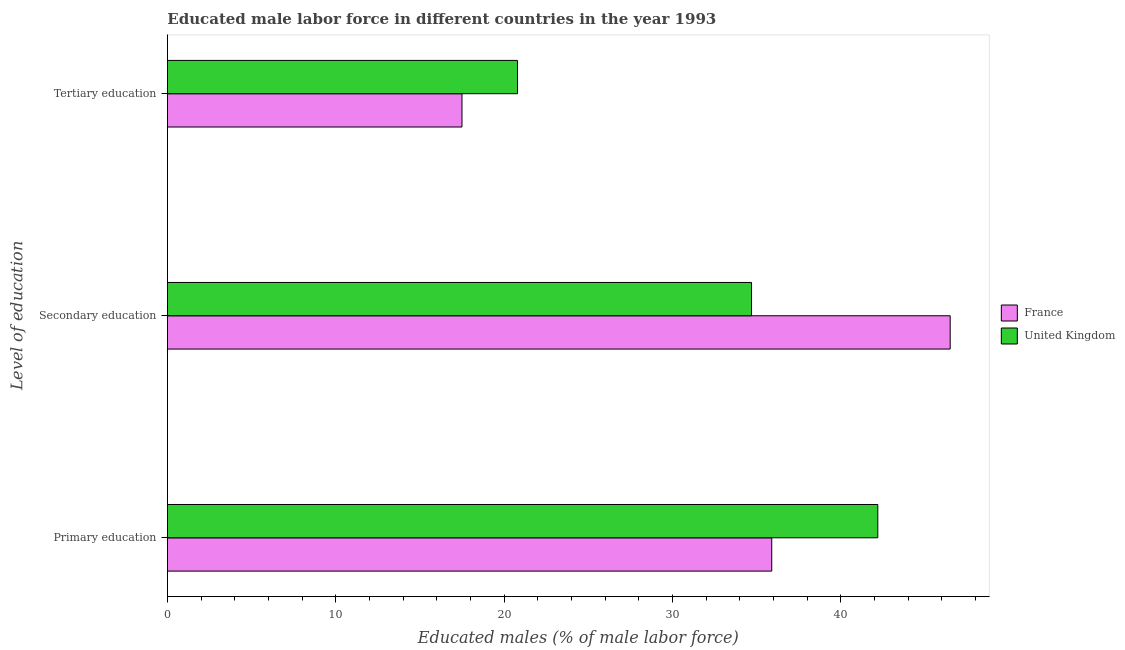Are the number of bars on each tick of the Y-axis equal?
Offer a very short reply. Yes. How many bars are there on the 1st tick from the top?
Your answer should be very brief. 2. What is the label of the 1st group of bars from the top?
Provide a succinct answer. Tertiary education. What is the percentage of male labor force who received primary education in United Kingdom?
Offer a very short reply. 42.2. Across all countries, what is the maximum percentage of male labor force who received primary education?
Offer a terse response. 42.2. Across all countries, what is the minimum percentage of male labor force who received primary education?
Offer a terse response. 35.9. In which country was the percentage of male labor force who received tertiary education maximum?
Provide a succinct answer. United Kingdom. What is the total percentage of male labor force who received secondary education in the graph?
Your answer should be compact. 81.2. What is the difference between the percentage of male labor force who received primary education in France and that in United Kingdom?
Your response must be concise. -6.3. What is the difference between the percentage of male labor force who received secondary education in United Kingdom and the percentage of male labor force who received tertiary education in France?
Make the answer very short. 17.2. What is the average percentage of male labor force who received secondary education per country?
Ensure brevity in your answer.  40.6. What is the difference between the percentage of male labor force who received primary education and percentage of male labor force who received tertiary education in United Kingdom?
Your response must be concise. 21.4. In how many countries, is the percentage of male labor force who received primary education greater than 4 %?
Provide a succinct answer. 2. What is the ratio of the percentage of male labor force who received secondary education in France to that in United Kingdom?
Provide a short and direct response. 1.34. What is the difference between the highest and the second highest percentage of male labor force who received primary education?
Your answer should be very brief. 6.3. What is the difference between the highest and the lowest percentage of male labor force who received primary education?
Provide a succinct answer. 6.3. What does the 1st bar from the bottom in Secondary education represents?
Your answer should be compact. France. How many bars are there?
Your response must be concise. 6. How many countries are there in the graph?
Offer a very short reply. 2. Does the graph contain any zero values?
Ensure brevity in your answer.  No. How are the legend labels stacked?
Keep it short and to the point. Vertical. What is the title of the graph?
Your response must be concise. Educated male labor force in different countries in the year 1993. Does "Kazakhstan" appear as one of the legend labels in the graph?
Your response must be concise. No. What is the label or title of the X-axis?
Offer a terse response. Educated males (% of male labor force). What is the label or title of the Y-axis?
Your answer should be very brief. Level of education. What is the Educated males (% of male labor force) of France in Primary education?
Provide a succinct answer. 35.9. What is the Educated males (% of male labor force) of United Kingdom in Primary education?
Make the answer very short. 42.2. What is the Educated males (% of male labor force) of France in Secondary education?
Make the answer very short. 46.5. What is the Educated males (% of male labor force) in United Kingdom in Secondary education?
Give a very brief answer. 34.7. What is the Educated males (% of male labor force) of United Kingdom in Tertiary education?
Make the answer very short. 20.8. Across all Level of education, what is the maximum Educated males (% of male labor force) of France?
Your response must be concise. 46.5. Across all Level of education, what is the maximum Educated males (% of male labor force) of United Kingdom?
Provide a succinct answer. 42.2. Across all Level of education, what is the minimum Educated males (% of male labor force) of France?
Your answer should be very brief. 17.5. Across all Level of education, what is the minimum Educated males (% of male labor force) in United Kingdom?
Offer a very short reply. 20.8. What is the total Educated males (% of male labor force) in France in the graph?
Ensure brevity in your answer.  99.9. What is the total Educated males (% of male labor force) in United Kingdom in the graph?
Provide a succinct answer. 97.7. What is the difference between the Educated males (% of male labor force) of France in Primary education and that in Secondary education?
Make the answer very short. -10.6. What is the difference between the Educated males (% of male labor force) of United Kingdom in Primary education and that in Tertiary education?
Your response must be concise. 21.4. What is the difference between the Educated males (% of male labor force) in France in Primary education and the Educated males (% of male labor force) in United Kingdom in Secondary education?
Give a very brief answer. 1.2. What is the difference between the Educated males (% of male labor force) in France in Primary education and the Educated males (% of male labor force) in United Kingdom in Tertiary education?
Your answer should be very brief. 15.1. What is the difference between the Educated males (% of male labor force) of France in Secondary education and the Educated males (% of male labor force) of United Kingdom in Tertiary education?
Offer a terse response. 25.7. What is the average Educated males (% of male labor force) of France per Level of education?
Offer a terse response. 33.3. What is the average Educated males (% of male labor force) in United Kingdom per Level of education?
Offer a terse response. 32.57. What is the difference between the Educated males (% of male labor force) of France and Educated males (% of male labor force) of United Kingdom in Primary education?
Your answer should be very brief. -6.3. What is the difference between the Educated males (% of male labor force) in France and Educated males (% of male labor force) in United Kingdom in Secondary education?
Your response must be concise. 11.8. What is the ratio of the Educated males (% of male labor force) of France in Primary education to that in Secondary education?
Your response must be concise. 0.77. What is the ratio of the Educated males (% of male labor force) of United Kingdom in Primary education to that in Secondary education?
Offer a terse response. 1.22. What is the ratio of the Educated males (% of male labor force) in France in Primary education to that in Tertiary education?
Your answer should be compact. 2.05. What is the ratio of the Educated males (% of male labor force) of United Kingdom in Primary education to that in Tertiary education?
Your answer should be very brief. 2.03. What is the ratio of the Educated males (% of male labor force) of France in Secondary education to that in Tertiary education?
Offer a very short reply. 2.66. What is the ratio of the Educated males (% of male labor force) in United Kingdom in Secondary education to that in Tertiary education?
Offer a very short reply. 1.67. What is the difference between the highest and the lowest Educated males (% of male labor force) in United Kingdom?
Your answer should be very brief. 21.4. 